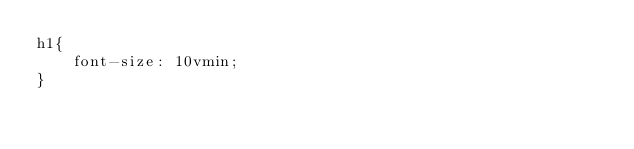Convert code to text. <code><loc_0><loc_0><loc_500><loc_500><_CSS_>h1{
	font-size: 10vmin;
}</code> 